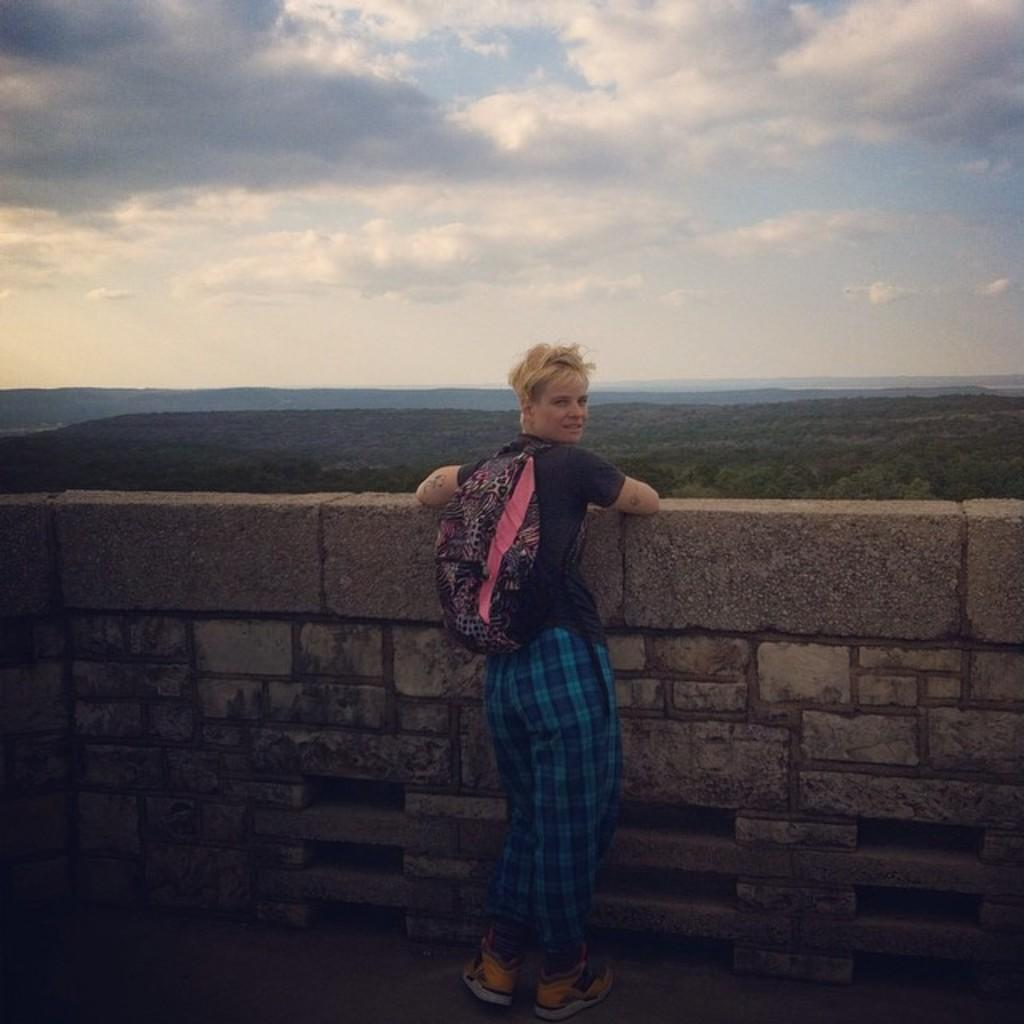What is the main subject of the image? There is a person standing in the image. What is the person wearing? The person is wearing a bag. What can be seen in the background of the image? There is a wall, trees, mountains, and the sky visible in the background of the image. What type of fruit is being harvested in the image? There is no fruit being harvested in the image; the focus is on the person standing and the background elements. What time of day is it in the image? The time of day cannot be determined from the image alone, as there are no specific clues or indicators of the time. 